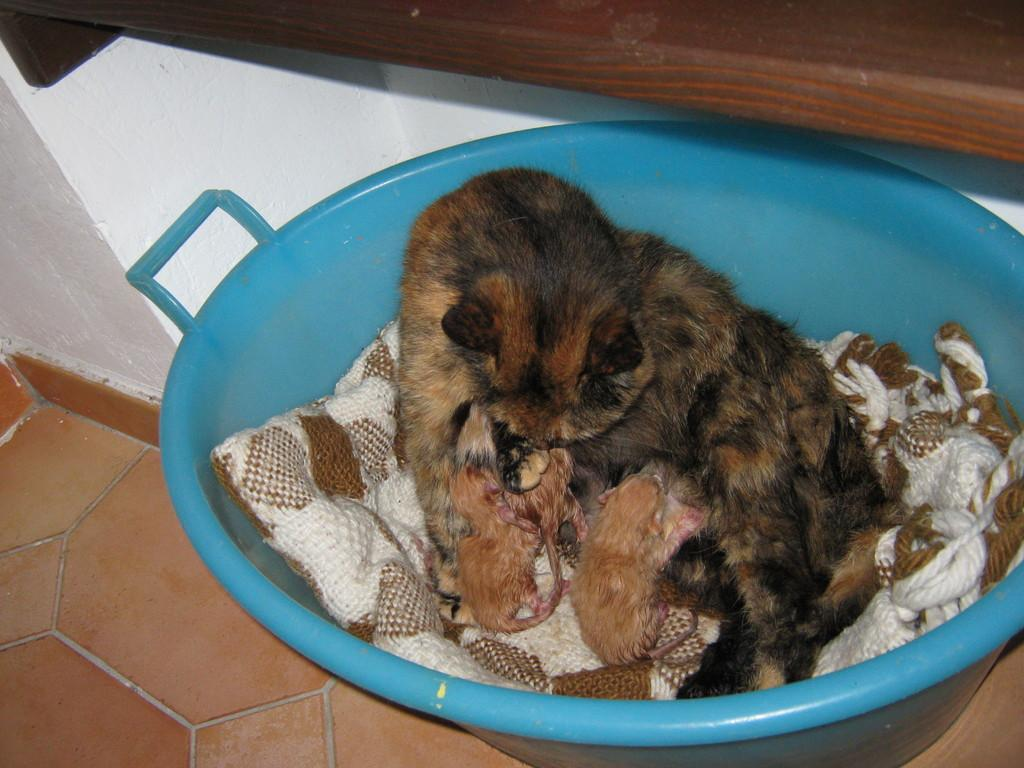What type of animal is in the image? There is a brown color cat in the image. Where is the cat sitting? The cat is sitting in a blue tub. Are there any other cats in the image? Yes, there are two baby kittens with the cat. What can be seen in the background of the image? There is a white wall and a wooden shelf visible in the background. What songs are the cats singing in the image? There are no songs being sung by the cats in the image; they are simply sitting in a tub and on the floor. Is there a hammer visible in the image? No, there is no hammer present in the image. 